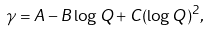<formula> <loc_0><loc_0><loc_500><loc_500>\gamma = A - B \log Q + C ( \log Q ) ^ { 2 } ,</formula> 